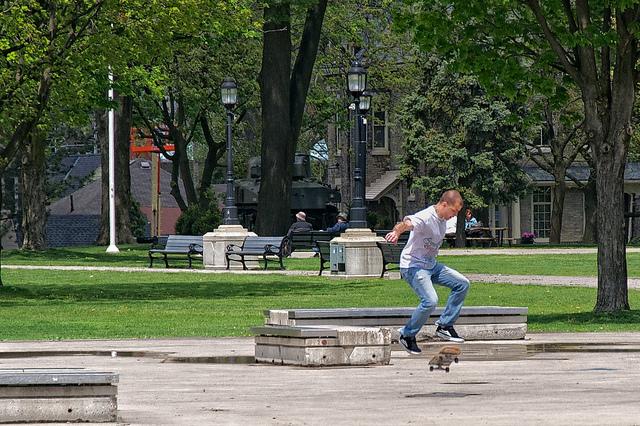Is this at a college?
Write a very short answer. Yes. What kind of pants is the man wearing?
Give a very brief answer. Jeans. What is the bench made of?
Be succinct. Cement. What sport is the man engaging in?
Be succinct. Skateboarding. 